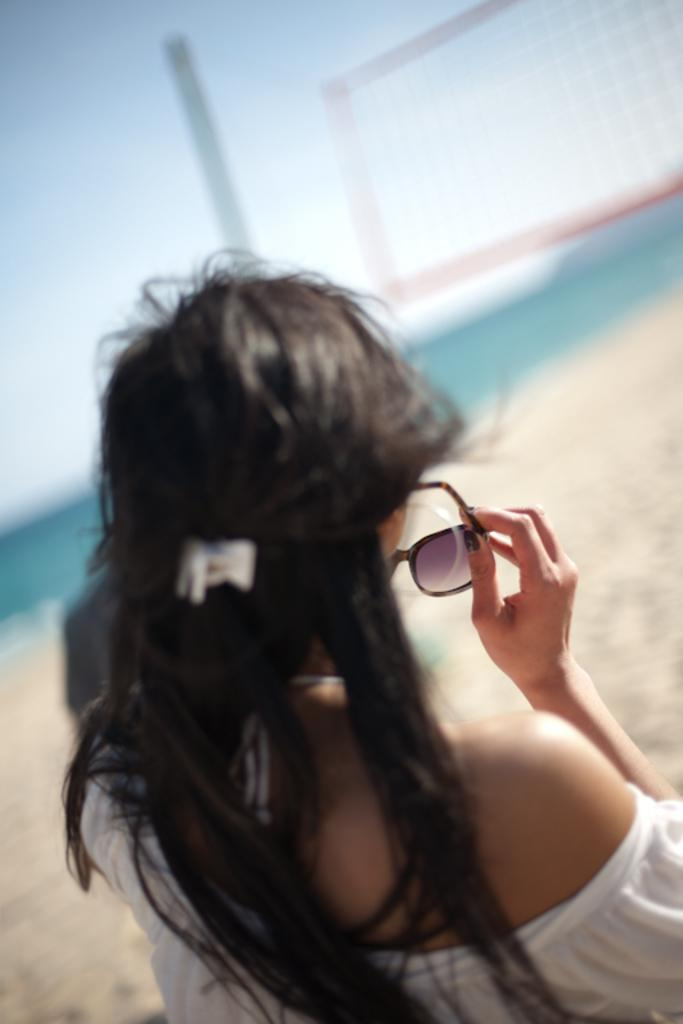What is the main subject of the image? There is a person in the image. What is the person holding in the image? The person is holding spectacles. Can you describe the background of the image? The background of the image is blurred. What type of writing can be seen on the pies in the image? There are no pies present in the image, so there is no writing on pies to be seen. 